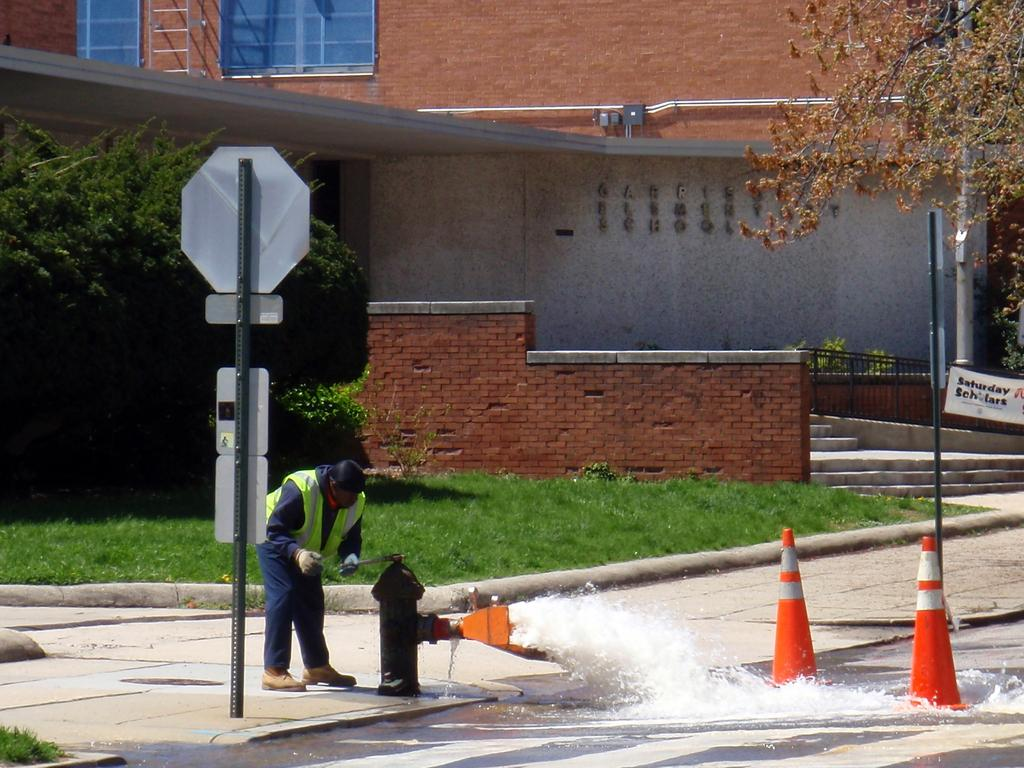What type of barriers are present in the image? There are cone barricades in the image. What is the source of the water in the image? Water is flowing from a fire hydrant in the image. What are the boards attached to in the image? The boards are attached to poles in the image. Can you describe the person in the image? There is a person standing in the image. What type of structure is visible in the image? There is a house in the image. What type of vegetation is present in the image? Grass and plants are visible in the image. What is the person doing with their chin in the image? There is no chin-related activity depicted in the image. How many bits are visible in the image? There are no bits present in the image. 